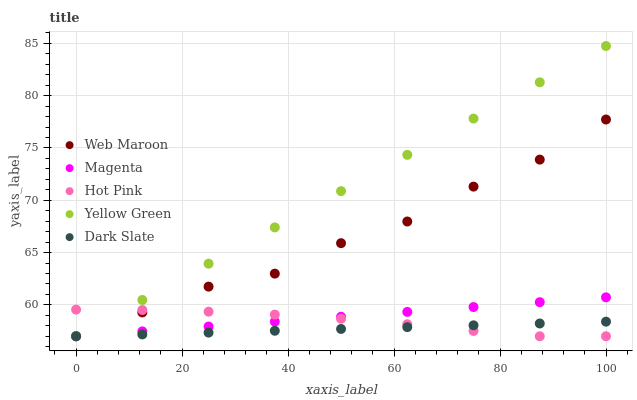Does Dark Slate have the minimum area under the curve?
Answer yes or no. Yes. Does Yellow Green have the maximum area under the curve?
Answer yes or no. Yes. Does Magenta have the minimum area under the curve?
Answer yes or no. No. Does Magenta have the maximum area under the curve?
Answer yes or no. No. Is Magenta the smoothest?
Answer yes or no. Yes. Is Web Maroon the roughest?
Answer yes or no. Yes. Is Hot Pink the smoothest?
Answer yes or no. No. Is Hot Pink the roughest?
Answer yes or no. No. Does Dark Slate have the lowest value?
Answer yes or no. Yes. Does Yellow Green have the highest value?
Answer yes or no. Yes. Does Magenta have the highest value?
Answer yes or no. No. Does Hot Pink intersect Web Maroon?
Answer yes or no. Yes. Is Hot Pink less than Web Maroon?
Answer yes or no. No. Is Hot Pink greater than Web Maroon?
Answer yes or no. No. 